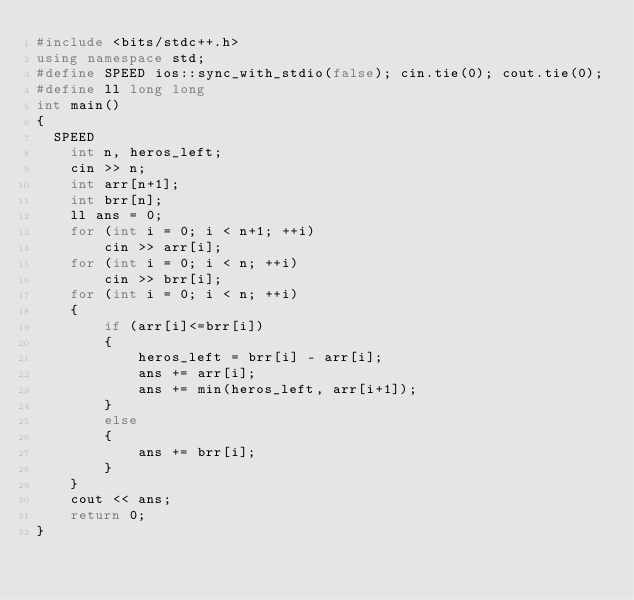Convert code to text. <code><loc_0><loc_0><loc_500><loc_500><_C++_>#include <bits/stdc++.h>
using namespace std;
#define SPEED ios::sync_with_stdio(false); cin.tie(0); cout.tie(0);
#define ll long long
int main() 
{ 
	SPEED
    int n, heros_left;
    cin >> n;
    int arr[n+1];
    int brr[n];
    ll ans = 0;
    for (int i = 0; i < n+1; ++i)
        cin >> arr[i];
    for (int i = 0; i < n; ++i)
        cin >> brr[i];
    for (int i = 0; i < n; ++i)
    {
        if (arr[i]<=brr[i])
        {
            heros_left = brr[i] - arr[i];
            ans += arr[i];
            ans += min(heros_left, arr[i+1]);
        }
        else
        {
            ans += brr[i];
        }
    }
    cout << ans;
    return 0;      
} </code> 